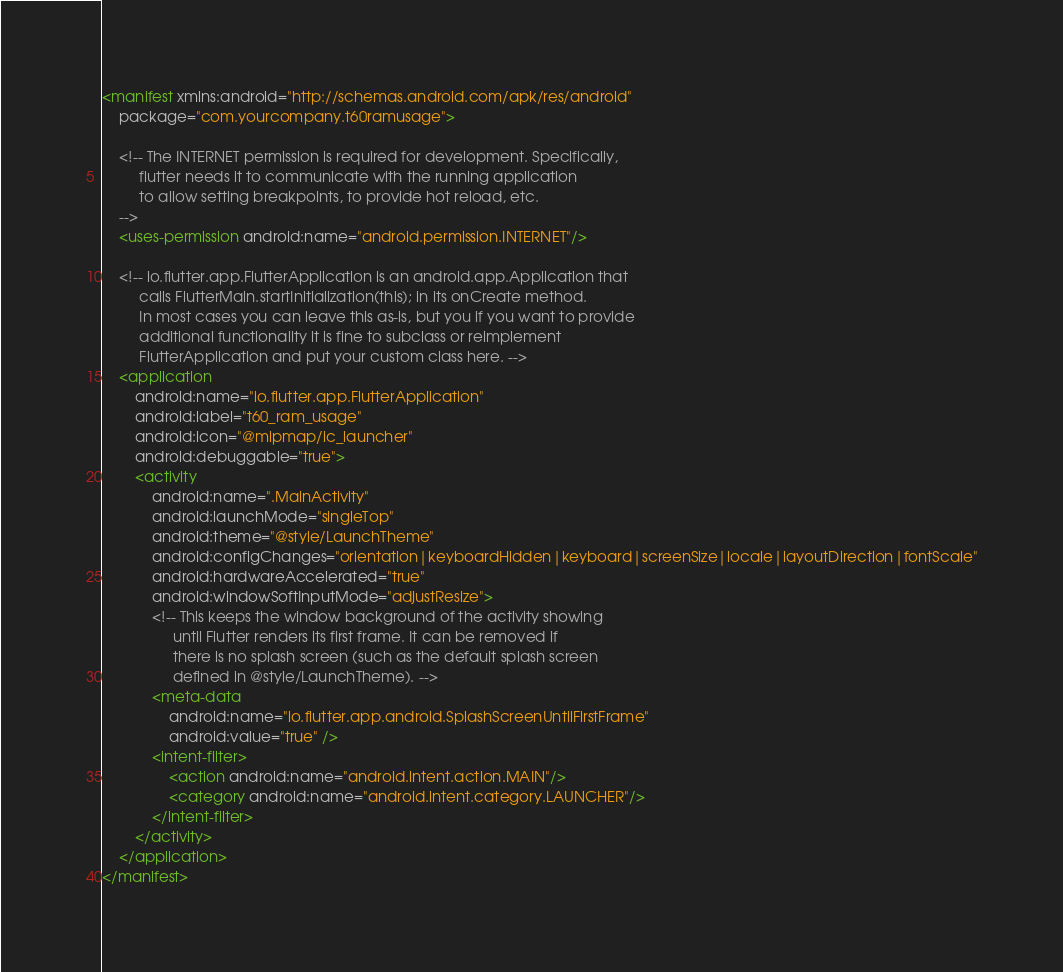Convert code to text. <code><loc_0><loc_0><loc_500><loc_500><_XML_><manifest xmlns:android="http://schemas.android.com/apk/res/android"
    package="com.yourcompany.t60ramusage">

    <!-- The INTERNET permission is required for development. Specifically,
         flutter needs it to communicate with the running application
         to allow setting breakpoints, to provide hot reload, etc.
    -->
    <uses-permission android:name="android.permission.INTERNET"/>

    <!-- io.flutter.app.FlutterApplication is an android.app.Application that
         calls FlutterMain.startInitialization(this); in its onCreate method.
         In most cases you can leave this as-is, but you if you want to provide
         additional functionality it is fine to subclass or reimplement
         FlutterApplication and put your custom class here. -->
    <application
        android:name="io.flutter.app.FlutterApplication"
        android:label="t60_ram_usage"
        android:icon="@mipmap/ic_launcher"
        android:debuggable="true">
        <activity
            android:name=".MainActivity"
            android:launchMode="singleTop"
            android:theme="@style/LaunchTheme"
            android:configChanges="orientation|keyboardHidden|keyboard|screenSize|locale|layoutDirection|fontScale"
            android:hardwareAccelerated="true"
            android:windowSoftInputMode="adjustResize">
            <!-- This keeps the window background of the activity showing
                 until Flutter renders its first frame. It can be removed if
                 there is no splash screen (such as the default splash screen
                 defined in @style/LaunchTheme). -->
            <meta-data
                android:name="io.flutter.app.android.SplashScreenUntilFirstFrame"
                android:value="true" />
            <intent-filter>
                <action android:name="android.intent.action.MAIN"/>
                <category android:name="android.intent.category.LAUNCHER"/>
            </intent-filter>
        </activity>
    </application>
</manifest>
</code> 